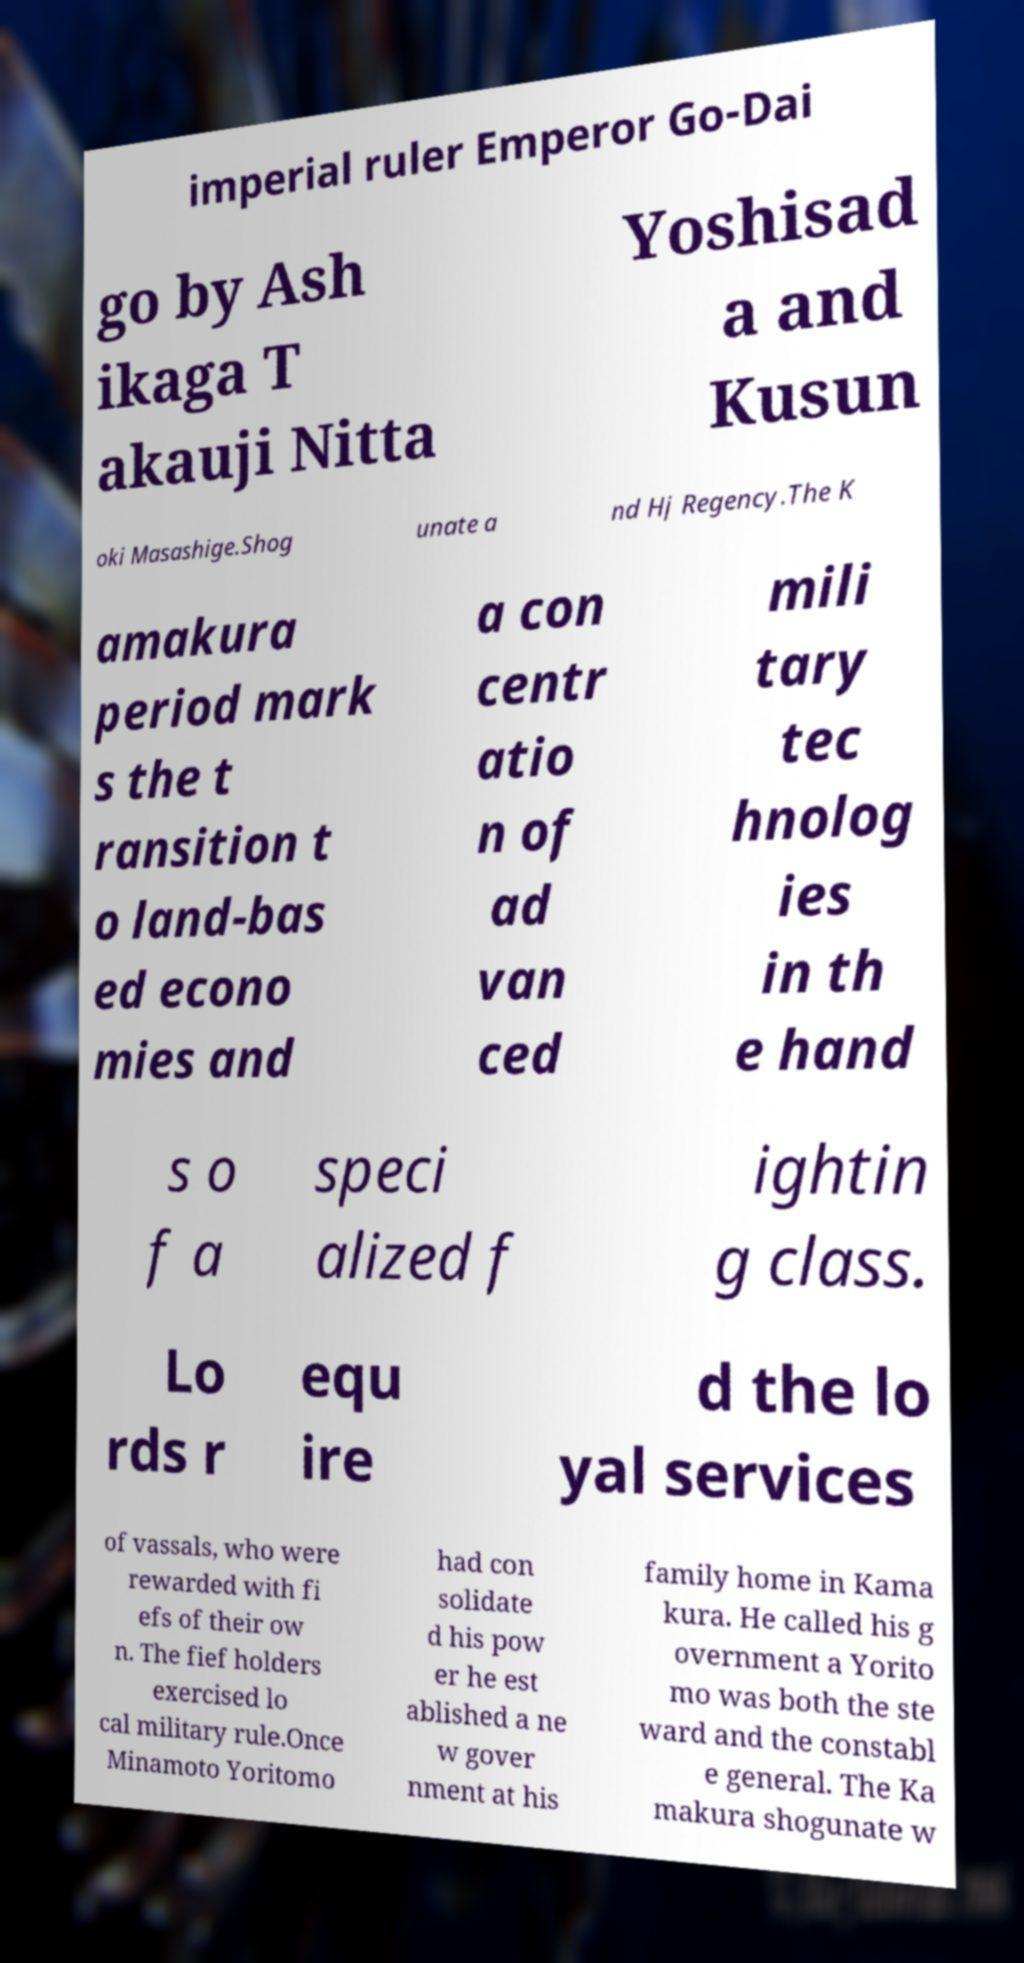For documentation purposes, I need the text within this image transcribed. Could you provide that? imperial ruler Emperor Go-Dai go by Ash ikaga T akauji Nitta Yoshisad a and Kusun oki Masashige.Shog unate a nd Hj Regency.The K amakura period mark s the t ransition t o land-bas ed econo mies and a con centr atio n of ad van ced mili tary tec hnolog ies in th e hand s o f a speci alized f ightin g class. Lo rds r equ ire d the lo yal services of vassals, who were rewarded with fi efs of their ow n. The fief holders exercised lo cal military rule.Once Minamoto Yoritomo had con solidate d his pow er he est ablished a ne w gover nment at his family home in Kama kura. He called his g overnment a Yorito mo was both the ste ward and the constabl e general. The Ka makura shogunate w 